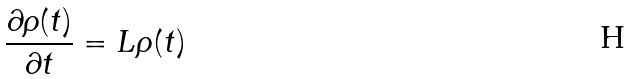Convert formula to latex. <formula><loc_0><loc_0><loc_500><loc_500>\frac { \partial \rho ( t ) } { \partial t } = L \rho ( t )</formula> 